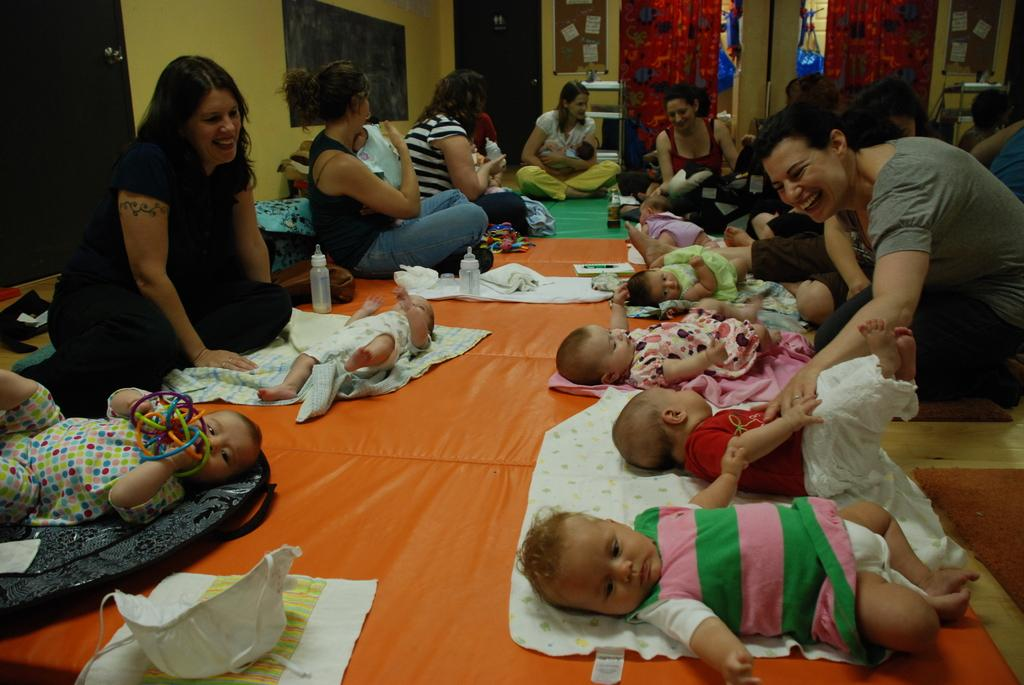What are the women in the image doing? There is a group of women sitting on the floor in the image. What are the children in the image doing? There is a group of children lying on the floor in the image. What objects can be seen in the image? Bottles are visible in the image. What items are related to clothing in the image? Clothes are present in the image. What can be seen in the background of the image? There are curtains and a wall in the background of the image. What type of heart-shaped object can be seen in the image? There is no heart-shaped object present in the image. What school-related activity is taking place in the image? There is no school-related activity depicted in the image. 